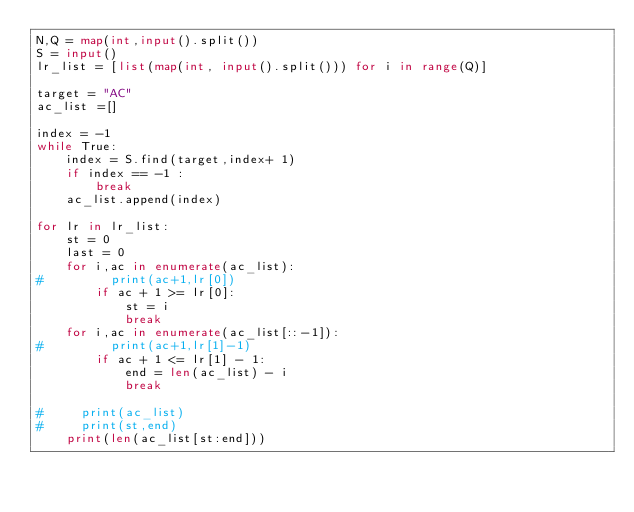<code> <loc_0><loc_0><loc_500><loc_500><_Python_>N,Q = map(int,input().split())
S = input()
lr_list = [list(map(int, input().split())) for i in range(Q)]

target = "AC"
ac_list =[]

index = -1
while True:
    index = S.find(target,index+ 1)
    if index == -1 :
        break
    ac_list.append(index)
    
for lr in lr_list:
    st = 0
    last = 0
    for i,ac in enumerate(ac_list):
#         print(ac+1,lr[0])
        if ac + 1 >= lr[0]:
            st = i
            break
    for i,ac in enumerate(ac_list[::-1]):
#         print(ac+1,lr[1]-1)
        if ac + 1 <= lr[1] - 1:
            end = len(ac_list) - i
            break
    
#     print(ac_list)
#     print(st,end)
    print(len(ac_list[st:end]))</code> 